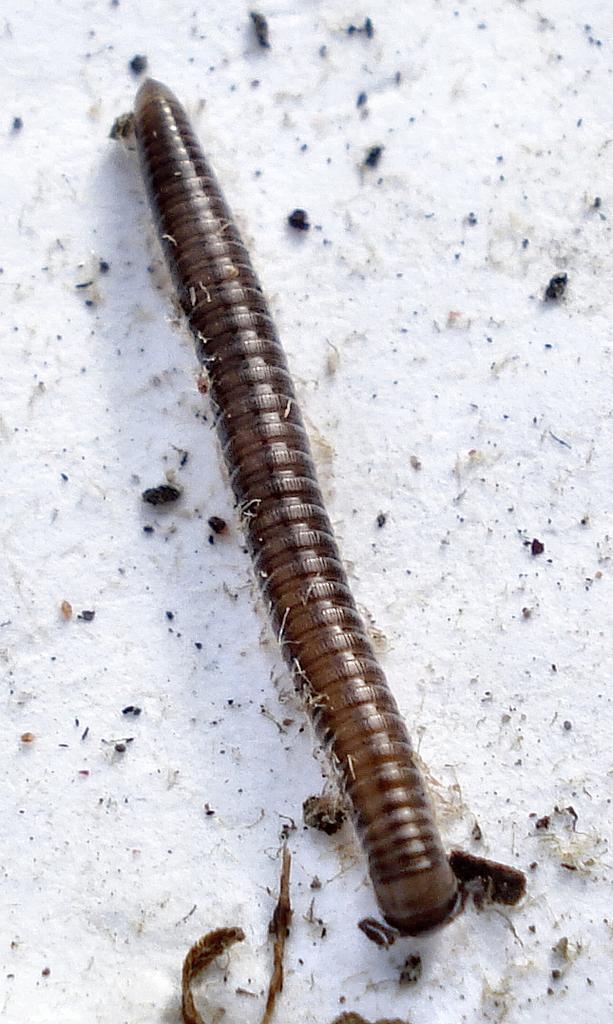Describe this image in one or two sentences. In the image we can see there is a caterpillar on the ground and there is snow on the ground. 